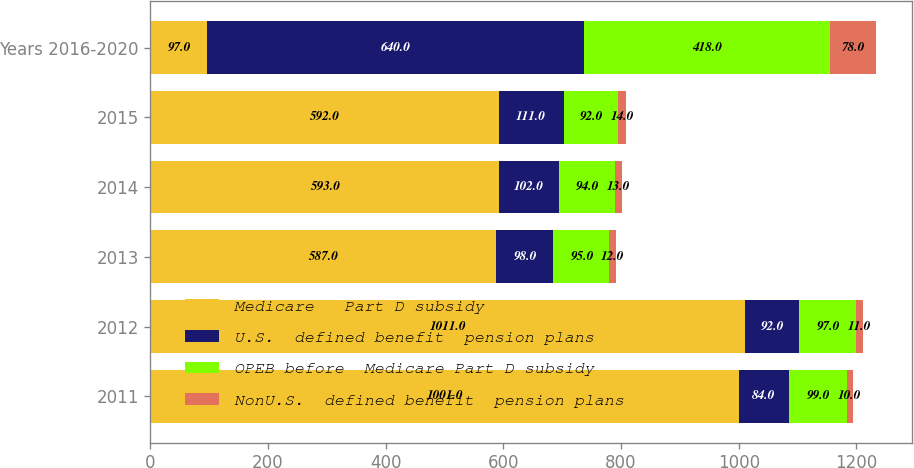Convert chart. <chart><loc_0><loc_0><loc_500><loc_500><stacked_bar_chart><ecel><fcel>2011<fcel>2012<fcel>2013<fcel>2014<fcel>2015<fcel>Years 2016-2020<nl><fcel>Medicare   Part D subsidy<fcel>1001<fcel>1011<fcel>587<fcel>593<fcel>592<fcel>97<nl><fcel>U.S.  defined benefit  pension plans<fcel>84<fcel>92<fcel>98<fcel>102<fcel>111<fcel>640<nl><fcel>OPEB before  Medicare Part D subsidy<fcel>99<fcel>97<fcel>95<fcel>94<fcel>92<fcel>418<nl><fcel>NonU.S.  defined benefit  pension plans<fcel>10<fcel>11<fcel>12<fcel>13<fcel>14<fcel>78<nl></chart> 